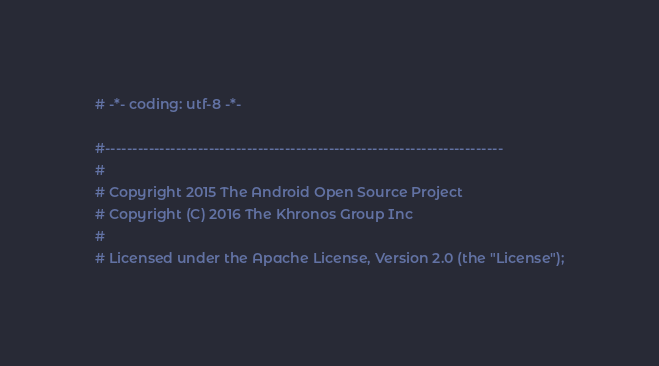<code> <loc_0><loc_0><loc_500><loc_500><_Python_># -*- coding: utf-8 -*-

#-------------------------------------------------------------------------
#
# Copyright 2015 The Android Open Source Project
# Copyright (C) 2016 The Khronos Group Inc
#
# Licensed under the Apache License, Version 2.0 (the "License");</code> 